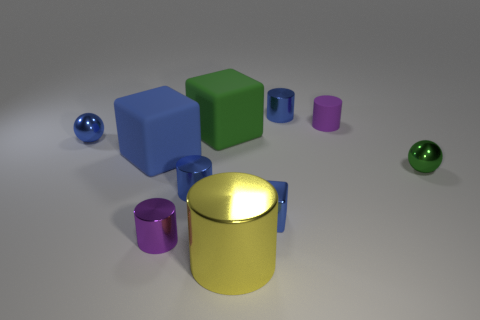Subtract all cyan balls. How many blue cubes are left? 2 Subtract all tiny blue cylinders. How many cylinders are left? 3 Subtract all cubes. How many objects are left? 7 Subtract all purple cylinders. How many cylinders are left? 3 Subtract 2 cylinders. How many cylinders are left? 3 Subtract all cylinders. Subtract all blue rubber things. How many objects are left? 4 Add 6 spheres. How many spheres are left? 8 Add 9 large cyan metallic things. How many large cyan metallic things exist? 9 Subtract 0 gray spheres. How many objects are left? 10 Subtract all cyan blocks. Subtract all green spheres. How many blocks are left? 3 